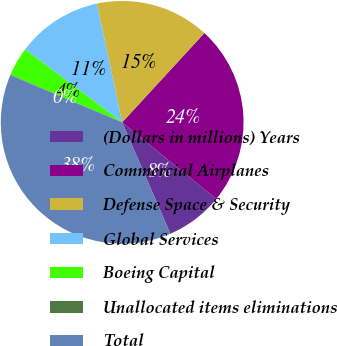<chart> <loc_0><loc_0><loc_500><loc_500><pie_chart><fcel>(Dollars in millions) Years<fcel>Commercial Airplanes<fcel>Defense Space & Security<fcel>Global Services<fcel>Boeing Capital<fcel>Unallocated items eliminations<fcel>Total<nl><fcel>7.63%<fcel>24.03%<fcel>15.18%<fcel>11.4%<fcel>3.85%<fcel>0.07%<fcel>37.84%<nl></chart> 